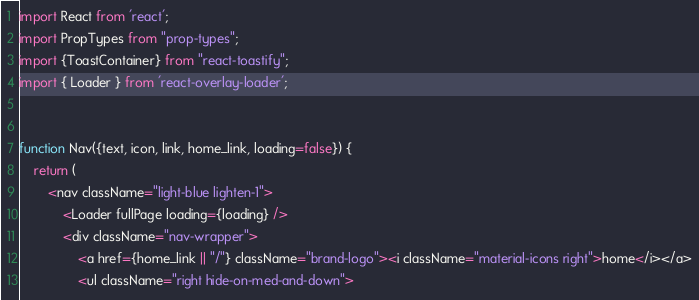<code> <loc_0><loc_0><loc_500><loc_500><_JavaScript_>import React from 'react';
import PropTypes from "prop-types";
import {ToastContainer} from "react-toastify";
import { Loader } from 'react-overlay-loader';


function Nav({text, icon, link, home_link, loading=false}) {
    return (
        <nav className="light-blue lighten-1">
            <Loader fullPage loading={loading} />
            <div className="nav-wrapper">
                <a href={home_link || "/"} className="brand-logo"><i className="material-icons right">home</i></a>
                <ul className="right hide-on-med-and-down"></code> 